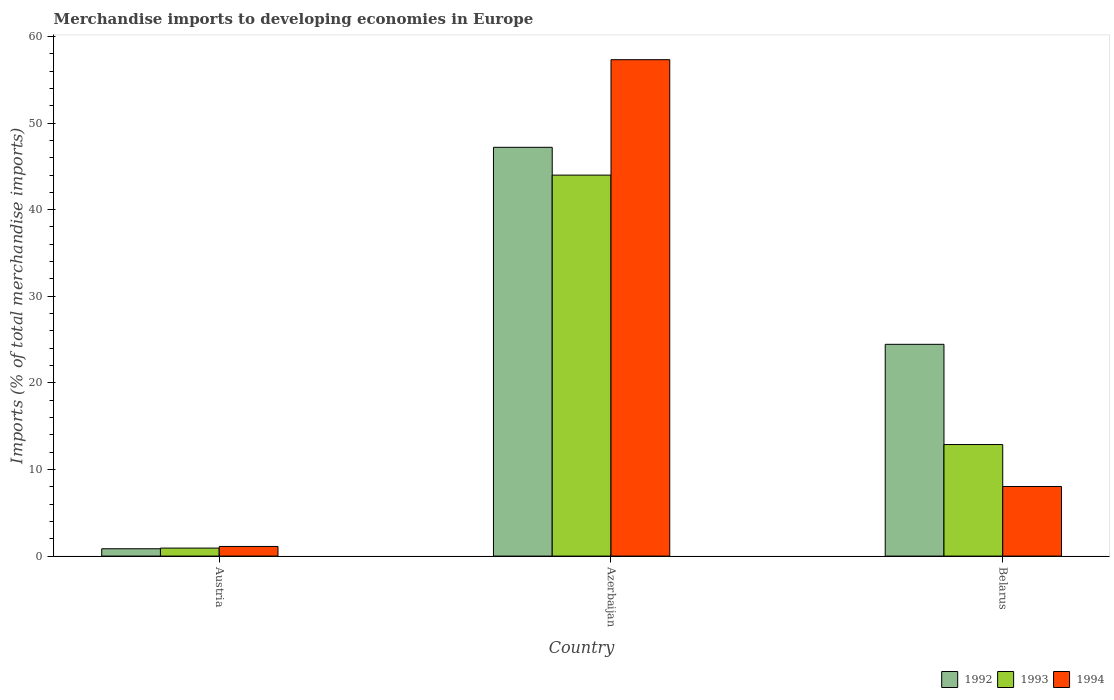How many bars are there on the 3rd tick from the left?
Your response must be concise. 3. How many bars are there on the 2nd tick from the right?
Give a very brief answer. 3. What is the label of the 2nd group of bars from the left?
Make the answer very short. Azerbaijan. What is the percentage total merchandise imports in 1992 in Belarus?
Provide a succinct answer. 24.45. Across all countries, what is the maximum percentage total merchandise imports in 1993?
Give a very brief answer. 43.99. Across all countries, what is the minimum percentage total merchandise imports in 1992?
Offer a very short reply. 0.85. In which country was the percentage total merchandise imports in 1992 maximum?
Offer a very short reply. Azerbaijan. What is the total percentage total merchandise imports in 1993 in the graph?
Offer a terse response. 57.79. What is the difference between the percentage total merchandise imports in 1994 in Austria and that in Azerbaijan?
Make the answer very short. -56.2. What is the difference between the percentage total merchandise imports in 1992 in Belarus and the percentage total merchandise imports in 1993 in Azerbaijan?
Your answer should be compact. -19.54. What is the average percentage total merchandise imports in 1993 per country?
Provide a short and direct response. 19.26. What is the difference between the percentage total merchandise imports of/in 1992 and percentage total merchandise imports of/in 1993 in Azerbaijan?
Give a very brief answer. 3.21. What is the ratio of the percentage total merchandise imports in 1992 in Azerbaijan to that in Belarus?
Provide a short and direct response. 1.93. Is the percentage total merchandise imports in 1994 in Azerbaijan less than that in Belarus?
Ensure brevity in your answer.  No. What is the difference between the highest and the second highest percentage total merchandise imports in 1993?
Your response must be concise. -43.06. What is the difference between the highest and the lowest percentage total merchandise imports in 1993?
Offer a very short reply. 43.06. Is it the case that in every country, the sum of the percentage total merchandise imports in 1994 and percentage total merchandise imports in 1992 is greater than the percentage total merchandise imports in 1993?
Offer a terse response. Yes. How many bars are there?
Your response must be concise. 9. Are all the bars in the graph horizontal?
Provide a succinct answer. No. What is the difference between two consecutive major ticks on the Y-axis?
Give a very brief answer. 10. Where does the legend appear in the graph?
Your answer should be compact. Bottom right. How many legend labels are there?
Your answer should be very brief. 3. How are the legend labels stacked?
Give a very brief answer. Horizontal. What is the title of the graph?
Offer a terse response. Merchandise imports to developing economies in Europe. Does "2001" appear as one of the legend labels in the graph?
Provide a succinct answer. No. What is the label or title of the X-axis?
Offer a very short reply. Country. What is the label or title of the Y-axis?
Make the answer very short. Imports (% of total merchandise imports). What is the Imports (% of total merchandise imports) of 1992 in Austria?
Keep it short and to the point. 0.85. What is the Imports (% of total merchandise imports) in 1993 in Austria?
Your answer should be very brief. 0.93. What is the Imports (% of total merchandise imports) of 1994 in Austria?
Make the answer very short. 1.11. What is the Imports (% of total merchandise imports) in 1992 in Azerbaijan?
Your response must be concise. 47.2. What is the Imports (% of total merchandise imports) in 1993 in Azerbaijan?
Give a very brief answer. 43.99. What is the Imports (% of total merchandise imports) in 1994 in Azerbaijan?
Provide a short and direct response. 57.31. What is the Imports (% of total merchandise imports) of 1992 in Belarus?
Offer a very short reply. 24.45. What is the Imports (% of total merchandise imports) of 1993 in Belarus?
Provide a succinct answer. 12.88. What is the Imports (% of total merchandise imports) in 1994 in Belarus?
Your answer should be very brief. 8.04. Across all countries, what is the maximum Imports (% of total merchandise imports) of 1992?
Provide a short and direct response. 47.2. Across all countries, what is the maximum Imports (% of total merchandise imports) in 1993?
Provide a succinct answer. 43.99. Across all countries, what is the maximum Imports (% of total merchandise imports) in 1994?
Provide a succinct answer. 57.31. Across all countries, what is the minimum Imports (% of total merchandise imports) in 1992?
Ensure brevity in your answer.  0.85. Across all countries, what is the minimum Imports (% of total merchandise imports) of 1993?
Your answer should be very brief. 0.93. Across all countries, what is the minimum Imports (% of total merchandise imports) in 1994?
Your answer should be compact. 1.11. What is the total Imports (% of total merchandise imports) of 1992 in the graph?
Your answer should be compact. 72.5. What is the total Imports (% of total merchandise imports) of 1993 in the graph?
Provide a short and direct response. 57.79. What is the total Imports (% of total merchandise imports) in 1994 in the graph?
Your response must be concise. 66.46. What is the difference between the Imports (% of total merchandise imports) of 1992 in Austria and that in Azerbaijan?
Make the answer very short. -46.35. What is the difference between the Imports (% of total merchandise imports) in 1993 in Austria and that in Azerbaijan?
Offer a very short reply. -43.06. What is the difference between the Imports (% of total merchandise imports) of 1994 in Austria and that in Azerbaijan?
Give a very brief answer. -56.2. What is the difference between the Imports (% of total merchandise imports) of 1992 in Austria and that in Belarus?
Offer a very short reply. -23.6. What is the difference between the Imports (% of total merchandise imports) of 1993 in Austria and that in Belarus?
Your response must be concise. -11.95. What is the difference between the Imports (% of total merchandise imports) of 1994 in Austria and that in Belarus?
Provide a succinct answer. -6.92. What is the difference between the Imports (% of total merchandise imports) of 1992 in Azerbaijan and that in Belarus?
Provide a short and direct response. 22.75. What is the difference between the Imports (% of total merchandise imports) in 1993 in Azerbaijan and that in Belarus?
Keep it short and to the point. 31.11. What is the difference between the Imports (% of total merchandise imports) of 1994 in Azerbaijan and that in Belarus?
Offer a terse response. 49.28. What is the difference between the Imports (% of total merchandise imports) of 1992 in Austria and the Imports (% of total merchandise imports) of 1993 in Azerbaijan?
Provide a succinct answer. -43.14. What is the difference between the Imports (% of total merchandise imports) in 1992 in Austria and the Imports (% of total merchandise imports) in 1994 in Azerbaijan?
Provide a succinct answer. -56.46. What is the difference between the Imports (% of total merchandise imports) of 1993 in Austria and the Imports (% of total merchandise imports) of 1994 in Azerbaijan?
Offer a very short reply. -56.39. What is the difference between the Imports (% of total merchandise imports) of 1992 in Austria and the Imports (% of total merchandise imports) of 1993 in Belarus?
Offer a terse response. -12.03. What is the difference between the Imports (% of total merchandise imports) in 1992 in Austria and the Imports (% of total merchandise imports) in 1994 in Belarus?
Provide a succinct answer. -7.19. What is the difference between the Imports (% of total merchandise imports) of 1993 in Austria and the Imports (% of total merchandise imports) of 1994 in Belarus?
Keep it short and to the point. -7.11. What is the difference between the Imports (% of total merchandise imports) of 1992 in Azerbaijan and the Imports (% of total merchandise imports) of 1993 in Belarus?
Your answer should be very brief. 34.32. What is the difference between the Imports (% of total merchandise imports) of 1992 in Azerbaijan and the Imports (% of total merchandise imports) of 1994 in Belarus?
Provide a succinct answer. 39.16. What is the difference between the Imports (% of total merchandise imports) of 1993 in Azerbaijan and the Imports (% of total merchandise imports) of 1994 in Belarus?
Give a very brief answer. 35.95. What is the average Imports (% of total merchandise imports) in 1992 per country?
Keep it short and to the point. 24.17. What is the average Imports (% of total merchandise imports) of 1993 per country?
Provide a short and direct response. 19.26. What is the average Imports (% of total merchandise imports) in 1994 per country?
Your response must be concise. 22.15. What is the difference between the Imports (% of total merchandise imports) in 1992 and Imports (% of total merchandise imports) in 1993 in Austria?
Your response must be concise. -0.08. What is the difference between the Imports (% of total merchandise imports) of 1992 and Imports (% of total merchandise imports) of 1994 in Austria?
Make the answer very short. -0.26. What is the difference between the Imports (% of total merchandise imports) in 1993 and Imports (% of total merchandise imports) in 1994 in Austria?
Provide a short and direct response. -0.19. What is the difference between the Imports (% of total merchandise imports) of 1992 and Imports (% of total merchandise imports) of 1993 in Azerbaijan?
Ensure brevity in your answer.  3.21. What is the difference between the Imports (% of total merchandise imports) in 1992 and Imports (% of total merchandise imports) in 1994 in Azerbaijan?
Your answer should be very brief. -10.11. What is the difference between the Imports (% of total merchandise imports) of 1993 and Imports (% of total merchandise imports) of 1994 in Azerbaijan?
Offer a very short reply. -13.33. What is the difference between the Imports (% of total merchandise imports) in 1992 and Imports (% of total merchandise imports) in 1993 in Belarus?
Your response must be concise. 11.57. What is the difference between the Imports (% of total merchandise imports) of 1992 and Imports (% of total merchandise imports) of 1994 in Belarus?
Keep it short and to the point. 16.41. What is the difference between the Imports (% of total merchandise imports) in 1993 and Imports (% of total merchandise imports) in 1994 in Belarus?
Make the answer very short. 4.84. What is the ratio of the Imports (% of total merchandise imports) in 1992 in Austria to that in Azerbaijan?
Your answer should be very brief. 0.02. What is the ratio of the Imports (% of total merchandise imports) in 1993 in Austria to that in Azerbaijan?
Your response must be concise. 0.02. What is the ratio of the Imports (% of total merchandise imports) in 1994 in Austria to that in Azerbaijan?
Your answer should be very brief. 0.02. What is the ratio of the Imports (% of total merchandise imports) of 1992 in Austria to that in Belarus?
Provide a short and direct response. 0.03. What is the ratio of the Imports (% of total merchandise imports) of 1993 in Austria to that in Belarus?
Provide a short and direct response. 0.07. What is the ratio of the Imports (% of total merchandise imports) in 1994 in Austria to that in Belarus?
Offer a very short reply. 0.14. What is the ratio of the Imports (% of total merchandise imports) in 1992 in Azerbaijan to that in Belarus?
Provide a succinct answer. 1.93. What is the ratio of the Imports (% of total merchandise imports) of 1993 in Azerbaijan to that in Belarus?
Provide a short and direct response. 3.42. What is the ratio of the Imports (% of total merchandise imports) of 1994 in Azerbaijan to that in Belarus?
Ensure brevity in your answer.  7.13. What is the difference between the highest and the second highest Imports (% of total merchandise imports) of 1992?
Keep it short and to the point. 22.75. What is the difference between the highest and the second highest Imports (% of total merchandise imports) of 1993?
Your response must be concise. 31.11. What is the difference between the highest and the second highest Imports (% of total merchandise imports) of 1994?
Make the answer very short. 49.28. What is the difference between the highest and the lowest Imports (% of total merchandise imports) of 1992?
Make the answer very short. 46.35. What is the difference between the highest and the lowest Imports (% of total merchandise imports) in 1993?
Offer a terse response. 43.06. What is the difference between the highest and the lowest Imports (% of total merchandise imports) in 1994?
Make the answer very short. 56.2. 